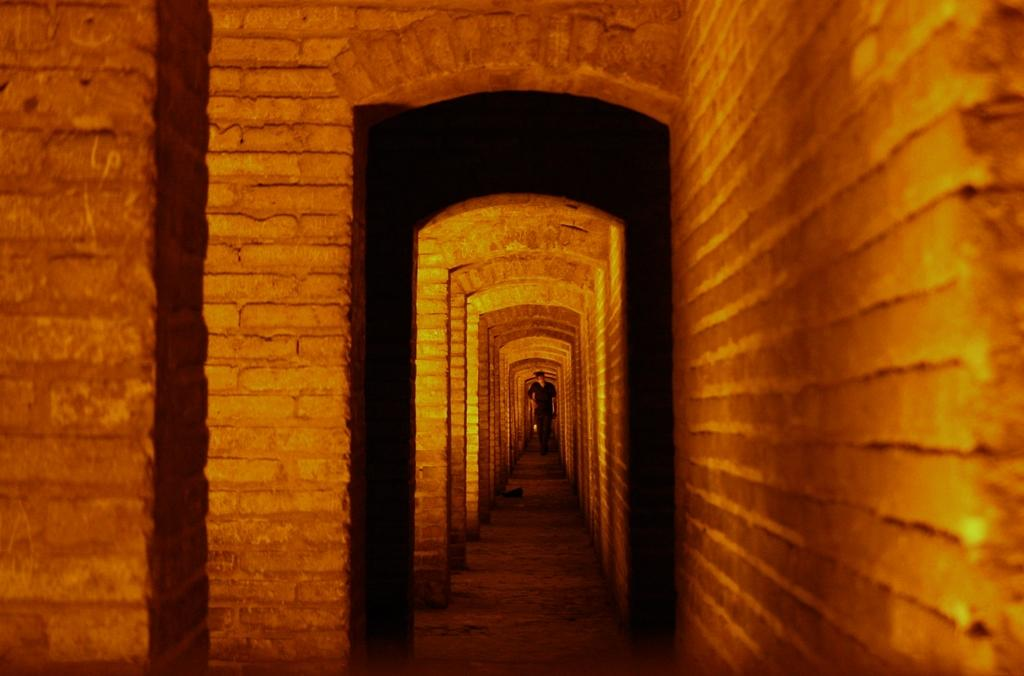Where is the image taken from? The image is taken from inside an architecture. What can be seen in the middle of the image? There are multiple arches present in the middle of the image. Are there any people visible in the image? Yes, there is one person standing beside the wall in the image. What type of bath is the person taking in the image? There is no bath present in the image; it is taken inside an architecture with arches and a person standing beside the wall. 